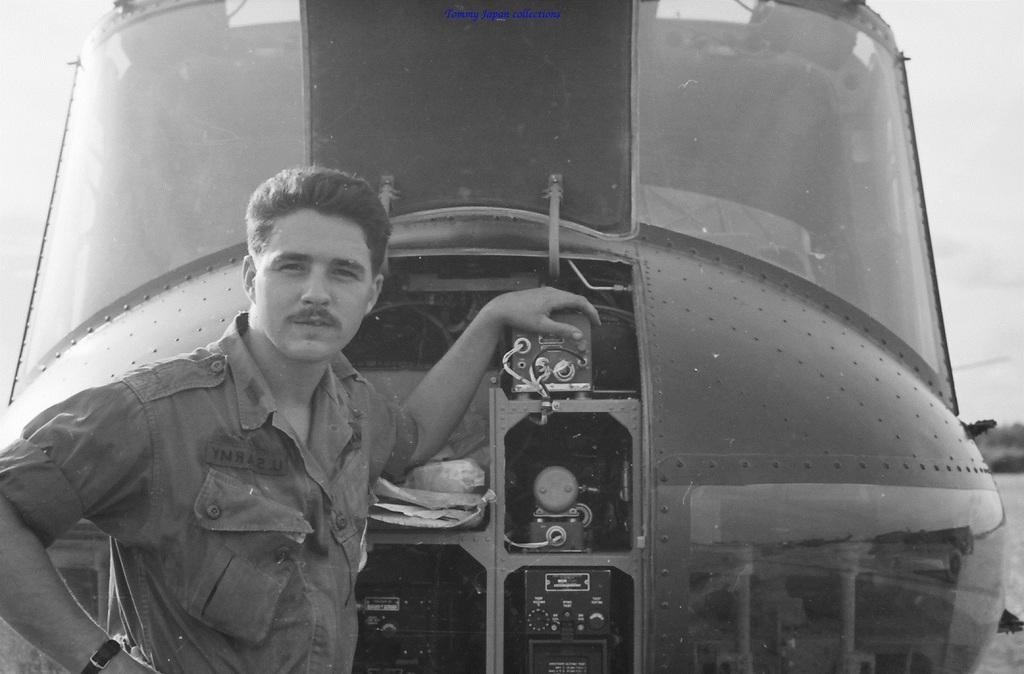Describe this image in one or two sentences. In this image I can see on the left side a man is standing by keeping his hand on a helicopter, he wore shirt and in the middle it is a helicopter. 